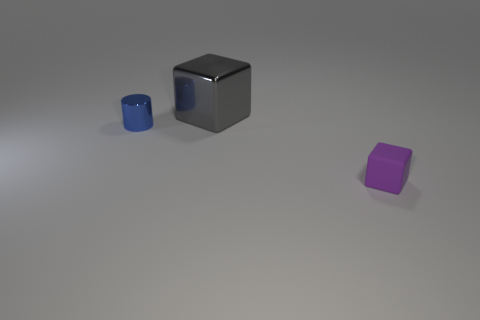Add 1 large blue metal balls. How many objects exist? 4 Subtract all cubes. How many objects are left? 1 Subtract all small purple spheres. Subtract all matte objects. How many objects are left? 2 Add 2 blue cylinders. How many blue cylinders are left? 3 Add 1 tiny gray metal cylinders. How many tiny gray metal cylinders exist? 1 Subtract 0 gray cylinders. How many objects are left? 3 